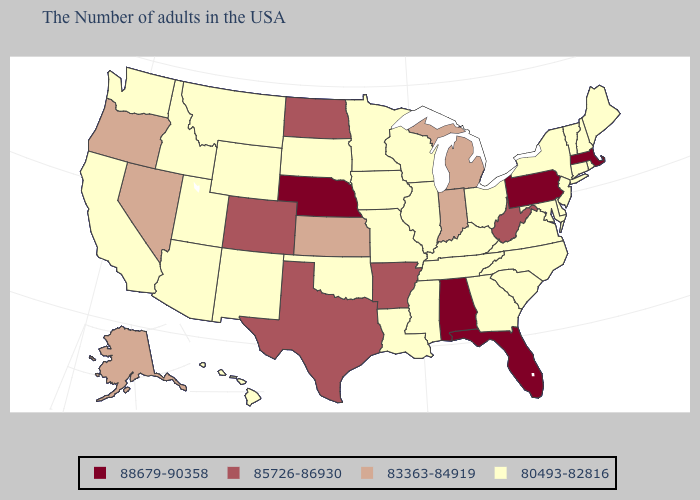Does Wisconsin have the highest value in the MidWest?
Concise answer only. No. Name the states that have a value in the range 80493-82816?
Keep it brief. Maine, Rhode Island, New Hampshire, Vermont, Connecticut, New York, New Jersey, Delaware, Maryland, Virginia, North Carolina, South Carolina, Ohio, Georgia, Kentucky, Tennessee, Wisconsin, Illinois, Mississippi, Louisiana, Missouri, Minnesota, Iowa, Oklahoma, South Dakota, Wyoming, New Mexico, Utah, Montana, Arizona, Idaho, California, Washington, Hawaii. Name the states that have a value in the range 88679-90358?
Answer briefly. Massachusetts, Pennsylvania, Florida, Alabama, Nebraska. Name the states that have a value in the range 85726-86930?
Keep it brief. West Virginia, Arkansas, Texas, North Dakota, Colorado. Name the states that have a value in the range 83363-84919?
Be succinct. Michigan, Indiana, Kansas, Nevada, Oregon, Alaska. Does Nevada have the same value as West Virginia?
Keep it brief. No. What is the highest value in the USA?
Be succinct. 88679-90358. Does Kentucky have the highest value in the USA?
Keep it brief. No. What is the value of Louisiana?
Short answer required. 80493-82816. Name the states that have a value in the range 88679-90358?
Concise answer only. Massachusetts, Pennsylvania, Florida, Alabama, Nebraska. Among the states that border New Hampshire , which have the highest value?
Answer briefly. Massachusetts. Name the states that have a value in the range 88679-90358?
Write a very short answer. Massachusetts, Pennsylvania, Florida, Alabama, Nebraska. What is the value of Georgia?
Be succinct. 80493-82816. Does the first symbol in the legend represent the smallest category?
Be succinct. No. Is the legend a continuous bar?
Quick response, please. No. 